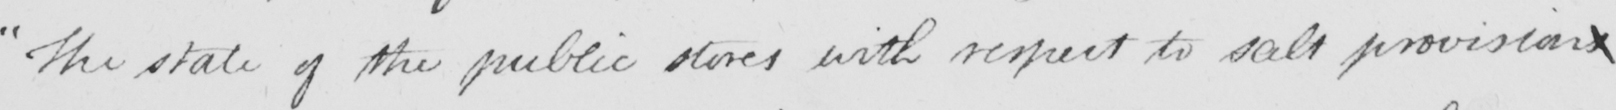What is written in this line of handwriting? The state of the public stores with respect to salt provisions 